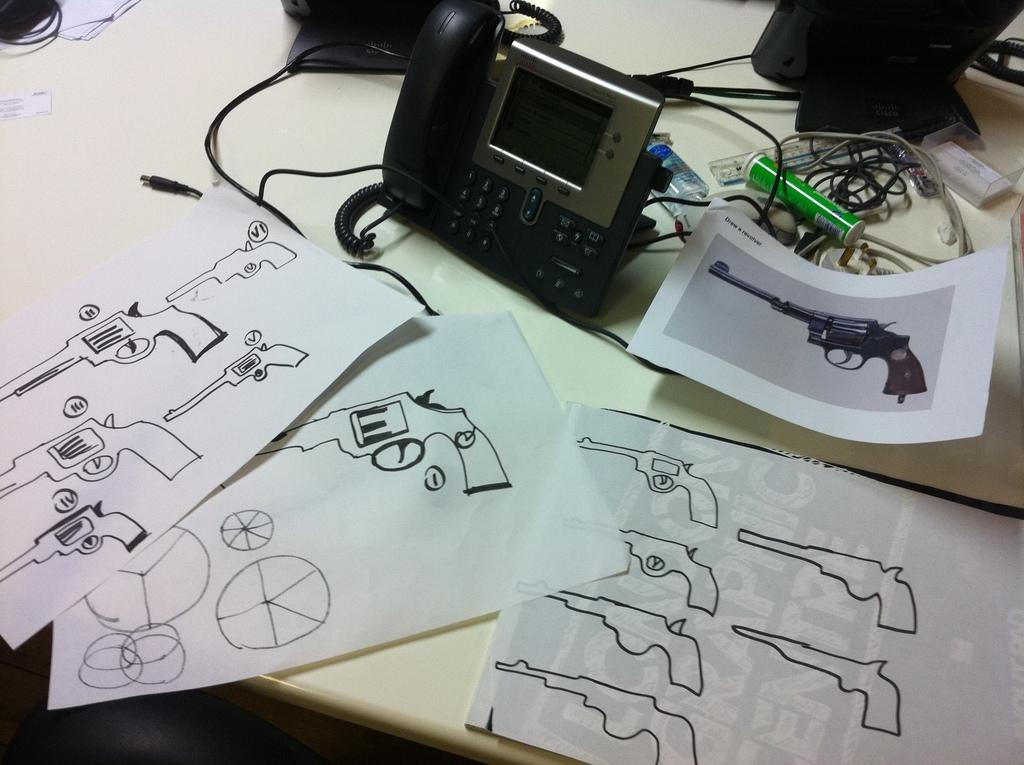What is the main piece of furniture in the image? There is a table in the image. What is on the table? The table contains papers and telephones, and there are cables and unspecified objects present as well. Can you see a cobweb hanging from the table in the image? There is no mention of a cobweb in the image, so it cannot be confirmed or denied. 